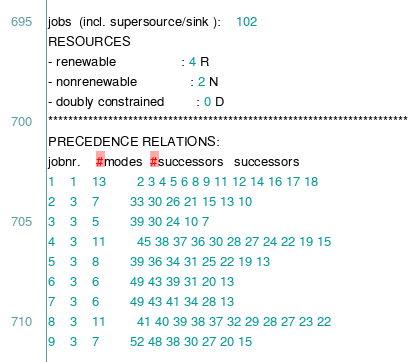Convert code to text. <code><loc_0><loc_0><loc_500><loc_500><_ObjectiveC_>jobs  (incl. supersource/sink ):	102
RESOURCES
- renewable                 : 4 R
- nonrenewable              : 2 N
- doubly constrained        : 0 D
************************************************************************
PRECEDENCE RELATIONS:
jobnr.    #modes  #successors   successors
1	1	13		2 3 4 5 6 8 9 11 12 14 16 17 18 
2	3	7		33 30 26 21 15 13 10 
3	3	5		39 30 24 10 7 
4	3	11		45 38 37 36 30 28 27 24 22 19 15 
5	3	8		39 36 34 31 25 22 19 13 
6	3	6		49 43 39 31 20 13 
7	3	6		49 43 41 34 28 13 
8	3	11		41 40 39 38 37 32 29 28 27 23 22 
9	3	7		52 48 38 30 27 20 15 </code> 